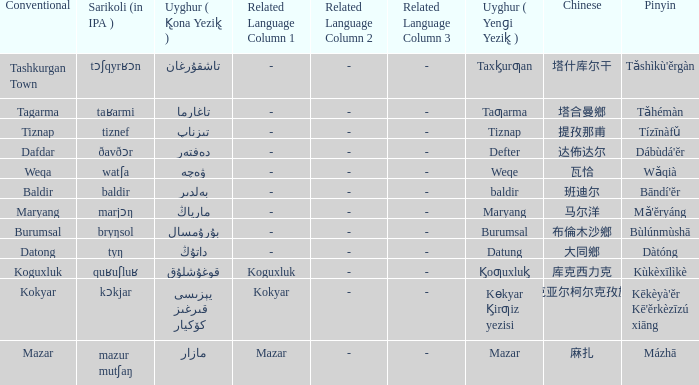Name the pinyin for  kɵkyar k̡irƣiz yezisi Kēkèyà'ěr Kē'ěrkèzīzú xiāng. 